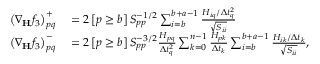<formula> <loc_0><loc_0><loc_500><loc_500>\begin{array} { r l } { \left ( \nabla _ { H } f _ { 3 } \right ) _ { p q } ^ { + } } & = 2 \left [ p \geq b \right ] S _ { p p } ^ { - 1 / 2 } \sum _ { i = b } ^ { b + a - 1 } \frac { H _ { i q } / \Delta t _ { q } ^ { 2 } } { \sqrt { S _ { i i } } } } \\ { \left ( \nabla _ { H } f _ { 3 } \right ) _ { p q } ^ { - } } & = 2 \left [ p \geq b \right ] S _ { p p } ^ { - 3 / 2 } \frac { H _ { p q } } { \Delta t _ { q } ^ { 2 } } \sum _ { k = 0 } ^ { n - 1 } \frac { H _ { p k } } { \Delta t _ { k } } \sum _ { i = b } ^ { b + a - 1 } \frac { H _ { i k } / \Delta t _ { k } } { \sqrt { S _ { i i } } } , } \end{array}</formula> 